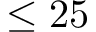Convert formula to latex. <formula><loc_0><loc_0><loc_500><loc_500>\leq 2 5</formula> 